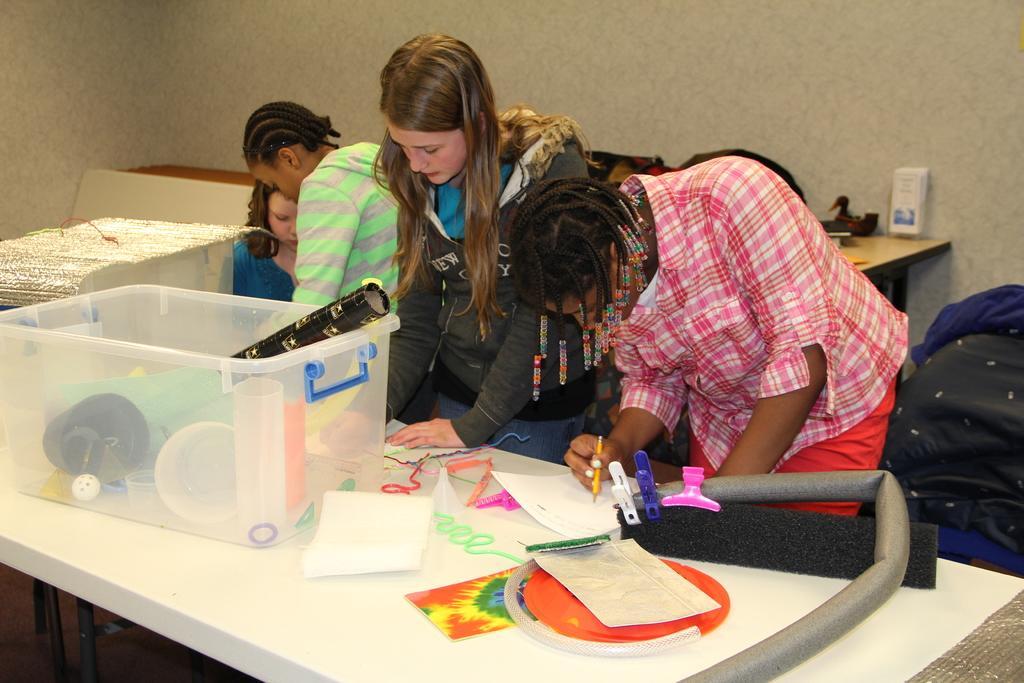Can you describe this image briefly? In this image there are four persons one,two,three are standing and the fourth person is sitting. The person one and person two are doing some work on paper which is kept on the table in front of them, on the table there is one box. In the background there is one table and a toy duck which is kept on that table. 